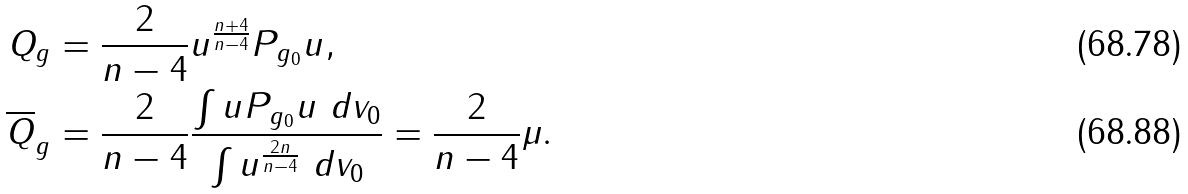Convert formula to latex. <formula><loc_0><loc_0><loc_500><loc_500>Q _ { g } & = \frac { 2 } { n - 4 } u ^ { \frac { n + 4 } { n - 4 } } P _ { g _ { 0 } } u , \\ \overline { Q } _ { g } & = \frac { 2 } { n - 4 } \frac { \int u P _ { g _ { 0 } } u \ d v _ { 0 } } { \int u ^ { \frac { 2 n } { n - 4 } } \ d v _ { 0 } } = \frac { 2 } { n - 4 } \mu .</formula> 